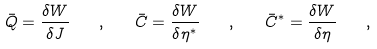Convert formula to latex. <formula><loc_0><loc_0><loc_500><loc_500>\bar { Q } = \frac { \delta W } { \delta J } \quad , \quad \bar { C } = \frac { \delta W } { \delta \eta ^ { \ast } } \quad , \quad \bar { C } ^ { \ast } = \frac { \delta W } { \delta \eta } \quad ,</formula> 